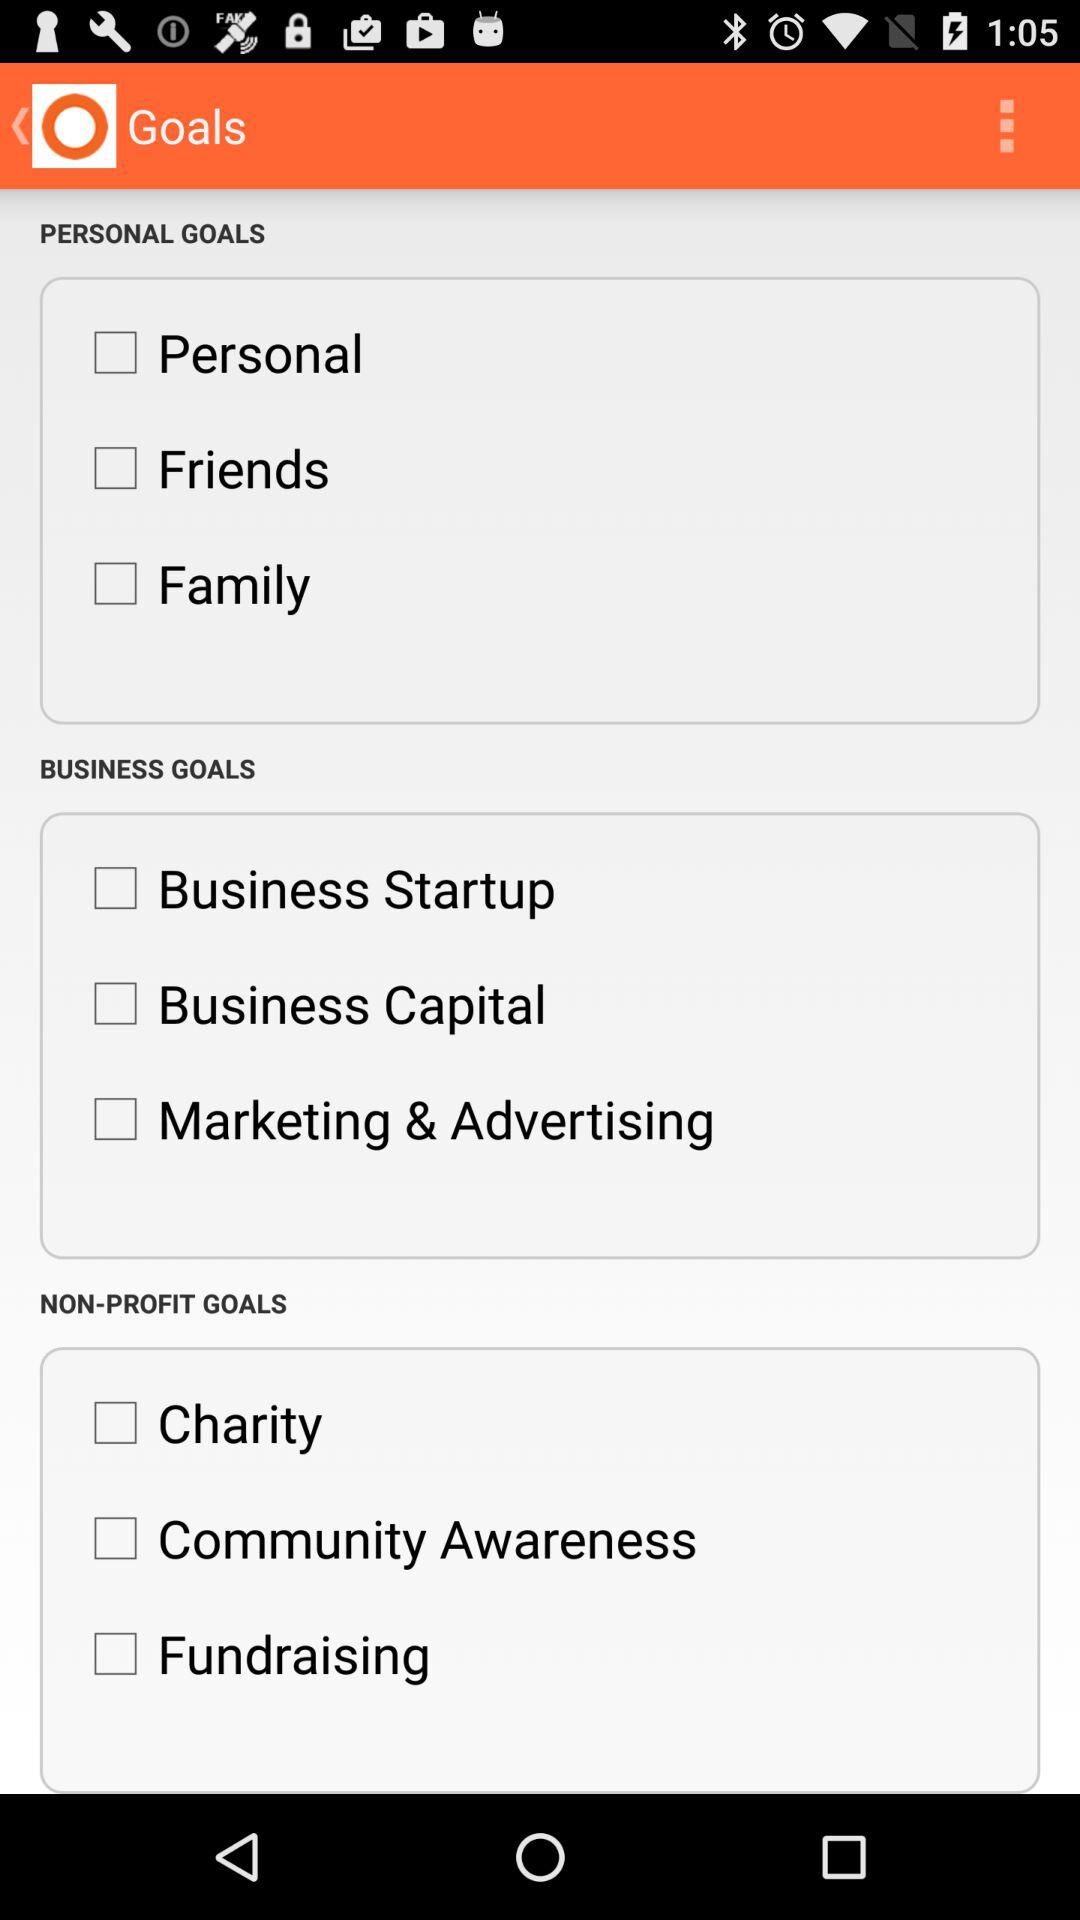How many non-profit goals are there?
Answer the question using a single word or phrase. 3 